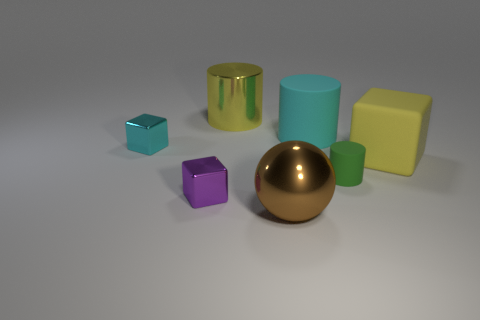Can you describe the arrangement of the objects on the surface? Certainly, the objects are arranged sporadically on a gray surface. In view, there is a golden sphere, a large sky blue cylinder, a purple cube, a smaller teal cube, a yellow rectangular block, and a reflective golden cylinder. They are evenly spaced and do not appear to be touching each other, creating a display of shapes and colors. 